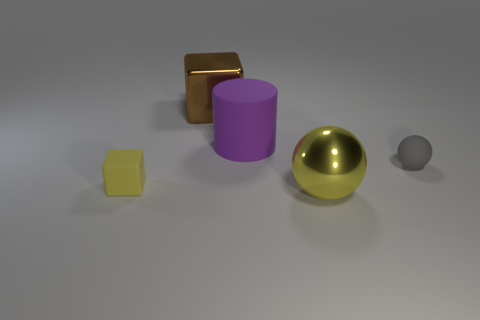Is the color of the large thing that is in front of the large purple matte thing the same as the shiny object that is behind the yellow matte object?
Provide a succinct answer. No. There is a yellow object in front of the small yellow block; what shape is it?
Offer a terse response. Sphere. What color is the large cylinder?
Your answer should be compact. Purple. What shape is the small thing that is made of the same material as the gray ball?
Keep it short and to the point. Cube. Is the size of the yellow thing on the right side of the cylinder the same as the gray thing?
Your answer should be compact. No. What number of objects are either yellow things to the right of the big brown shiny cube or spheres that are in front of the small block?
Offer a terse response. 1. Do the shiny object that is in front of the big purple cylinder and the big shiny block have the same color?
Ensure brevity in your answer.  No. How many matte things are either large purple things or large blocks?
Provide a short and direct response. 1. There is a big brown metal object; what shape is it?
Provide a short and direct response. Cube. Is there any other thing that has the same material as the brown cube?
Keep it short and to the point. Yes. 